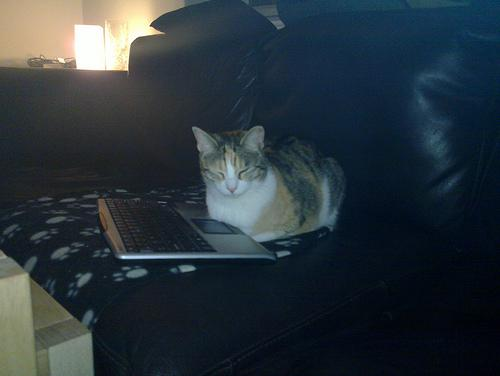Question: what color is the cat?
Choices:
A. Tricolor.
B. Black.
C. White.
D. Purple.
Answer with the letter. Answer: A 